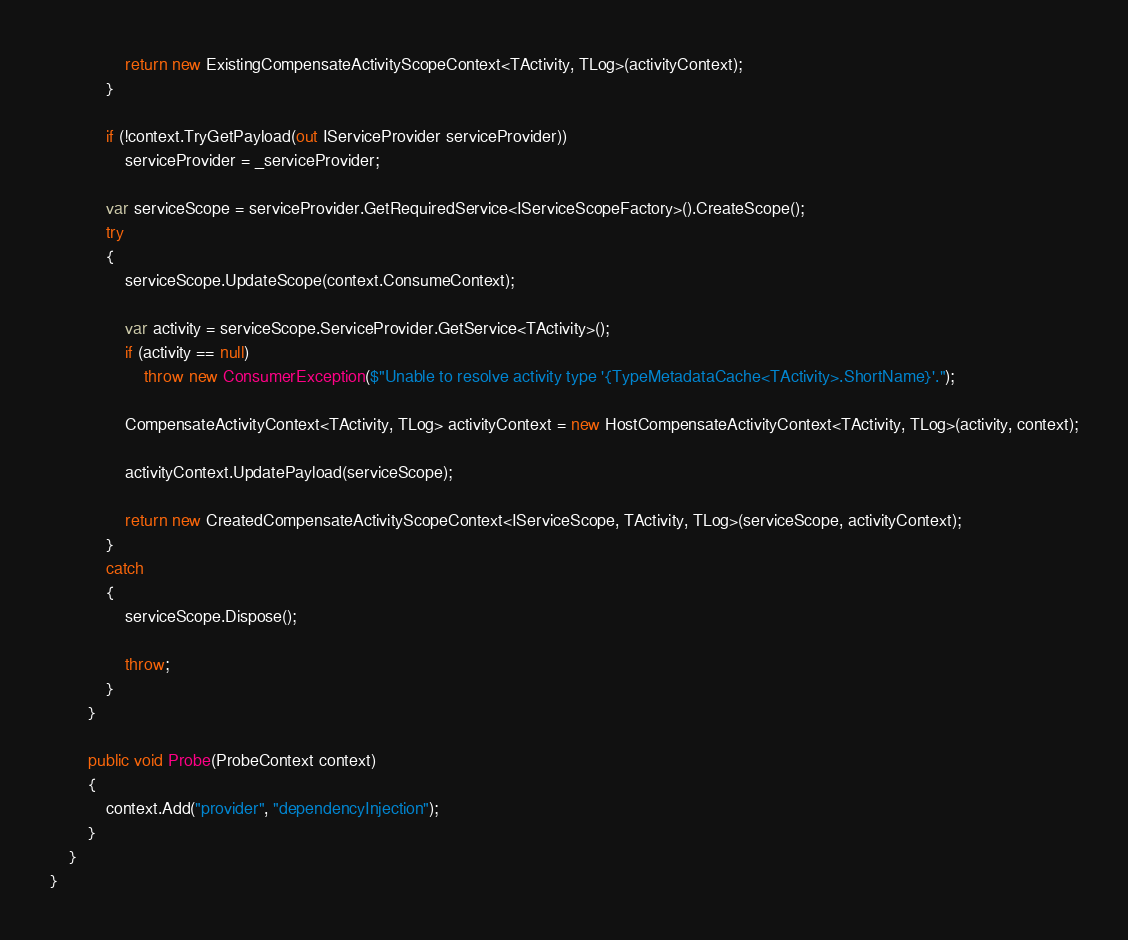Convert code to text. <code><loc_0><loc_0><loc_500><loc_500><_C#_>
                return new ExistingCompensateActivityScopeContext<TActivity, TLog>(activityContext);
            }

            if (!context.TryGetPayload(out IServiceProvider serviceProvider))
                serviceProvider = _serviceProvider;

            var serviceScope = serviceProvider.GetRequiredService<IServiceScopeFactory>().CreateScope();
            try
            {
                serviceScope.UpdateScope(context.ConsumeContext);

                var activity = serviceScope.ServiceProvider.GetService<TActivity>();
                if (activity == null)
                    throw new ConsumerException($"Unable to resolve activity type '{TypeMetadataCache<TActivity>.ShortName}'.");

                CompensateActivityContext<TActivity, TLog> activityContext = new HostCompensateActivityContext<TActivity, TLog>(activity, context);

                activityContext.UpdatePayload(serviceScope);

                return new CreatedCompensateActivityScopeContext<IServiceScope, TActivity, TLog>(serviceScope, activityContext);
            }
            catch
            {
                serviceScope.Dispose();

                throw;
            }
        }

        public void Probe(ProbeContext context)
        {
            context.Add("provider", "dependencyInjection");
        }
    }
}
</code> 